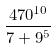Convert formula to latex. <formula><loc_0><loc_0><loc_500><loc_500>\frac { 4 7 0 ^ { 1 0 } } { 7 + 9 ^ { 5 } }</formula> 